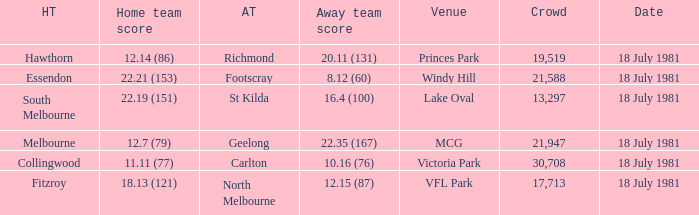What was the away team that played against Fitzroy? North Melbourne. 